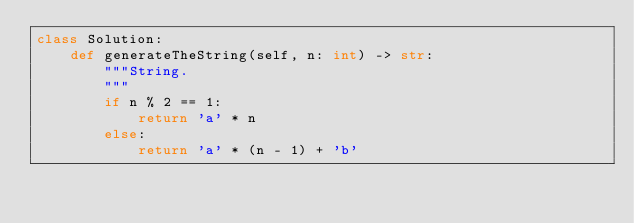<code> <loc_0><loc_0><loc_500><loc_500><_Python_>class Solution:
    def generateTheString(self, n: int) -> str:
    	"""String.
    	"""
        if n % 2 == 1:
            return 'a' * n
        else:
            return 'a' * (n - 1) + 'b'
</code> 